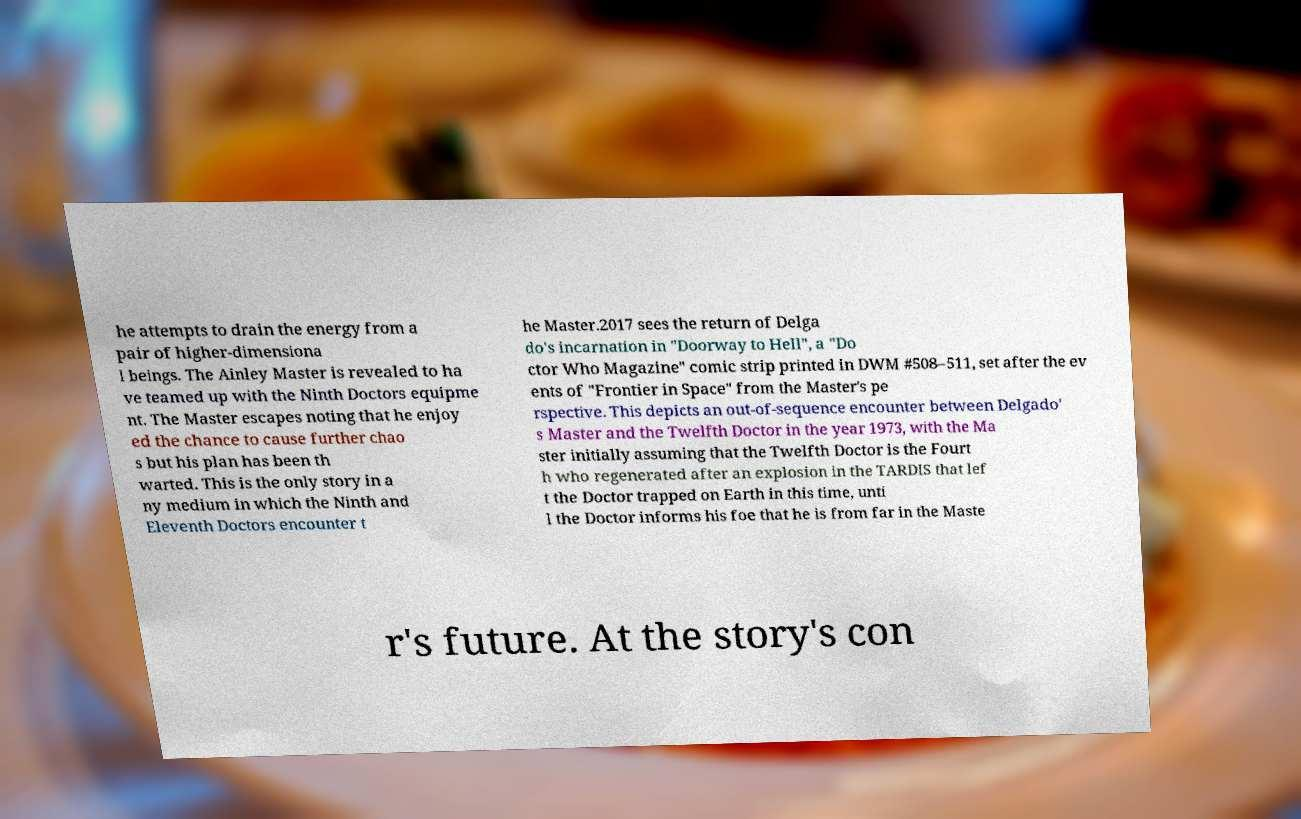Please identify and transcribe the text found in this image. he attempts to drain the energy from a pair of higher-dimensiona l beings. The Ainley Master is revealed to ha ve teamed up with the Ninth Doctors equipme nt. The Master escapes noting that he enjoy ed the chance to cause further chao s but his plan has been th warted. This is the only story in a ny medium in which the Ninth and Eleventh Doctors encounter t he Master.2017 sees the return of Delga do's incarnation in "Doorway to Hell", a "Do ctor Who Magazine" comic strip printed in DWM #508–511, set after the ev ents of "Frontier in Space" from the Master's pe rspective. This depicts an out-of-sequence encounter between Delgado' s Master and the Twelfth Doctor in the year 1973, with the Ma ster initially assuming that the Twelfth Doctor is the Fourt h who regenerated after an explosion in the TARDIS that lef t the Doctor trapped on Earth in this time, unti l the Doctor informs his foe that he is from far in the Maste r's future. At the story's con 